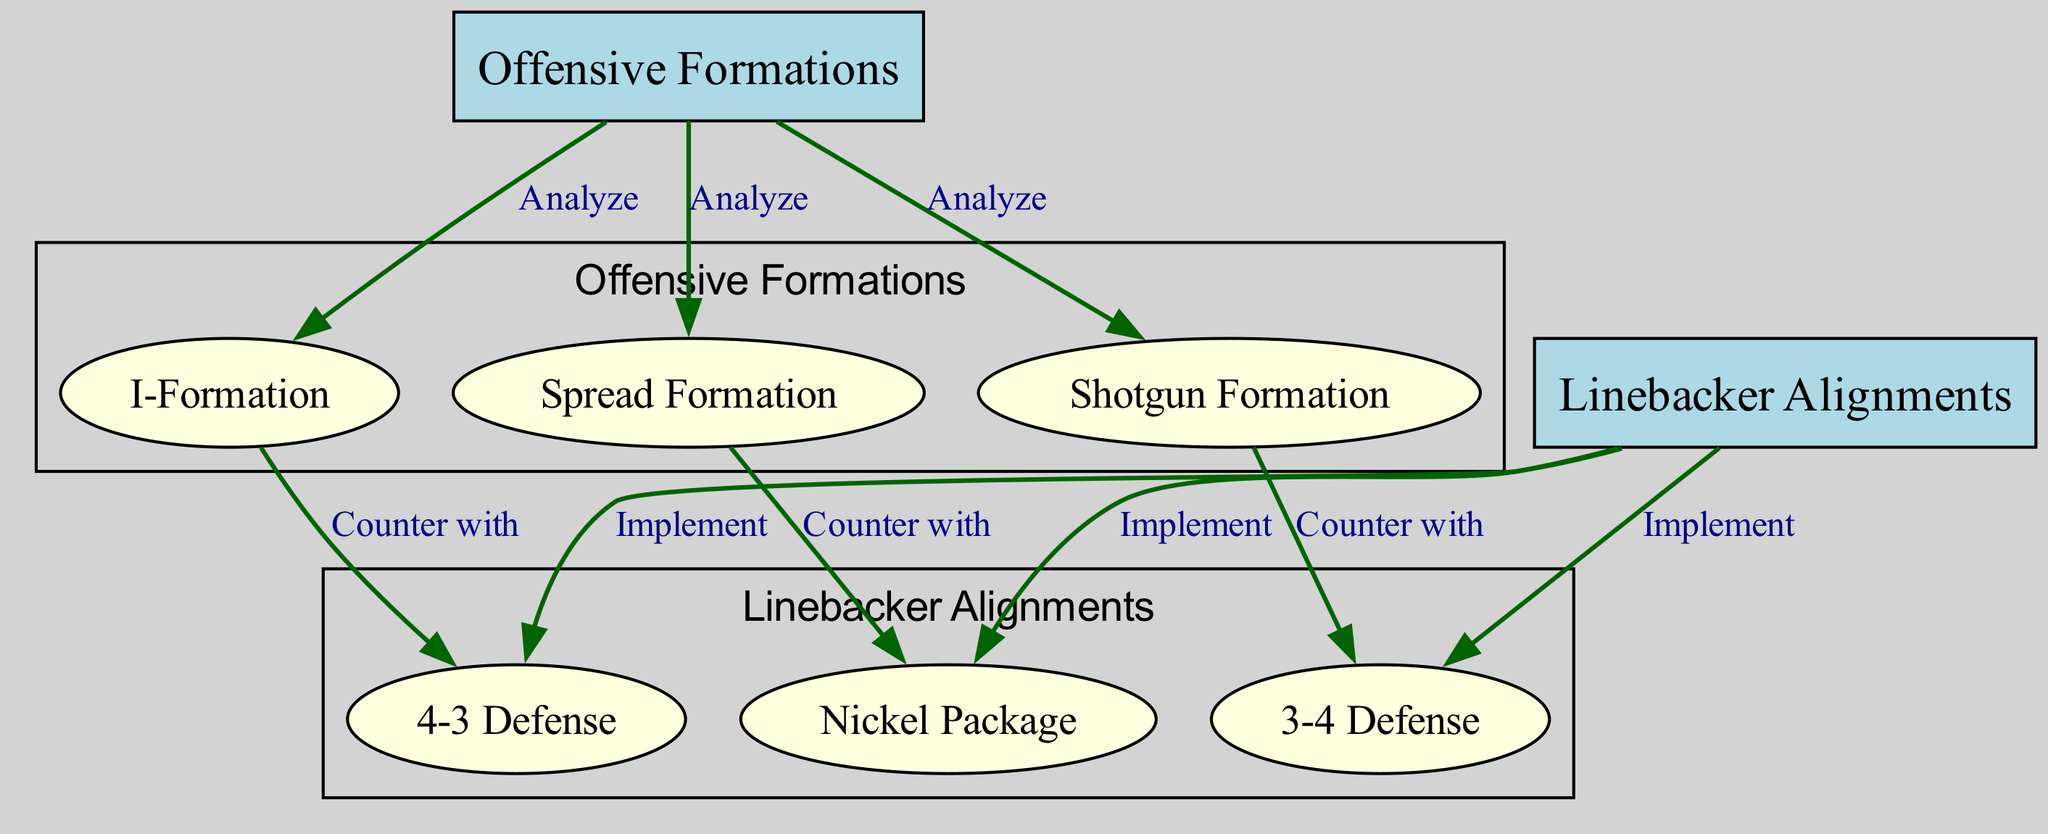What are the types of Offensive Formations listed? The diagram lists three types of offensive formations: Spread Formation, I-Formation, and Shotgun Formation. These are represented as individual nodes under the main node "Offensive Formations."
Answer: Spread Formation, I-Formation, Shotgun Formation What is the first layer of nodes in the diagram? The first layer contains two main nodes: "Offensive Formations" and "Linebacker Alignments." Under "Offensive Formations," there are three formations, while "Linebacker Alignments" leads to the three defensive schemes.
Answer: Offensive Formations, Linebacker Alignments How many nodes are connected to "Offensive Formations"? "Offensive Formations" connects to three nodes: Spread Formation, I-Formation, and Shotgun Formation, indicating the different types of formations analyzed.
Answer: 3 What does "Spread Formation" counter with? The label indicates that the "Spread Formation" is countered with the "Nickel Package," shown as an edge in the diagram connecting these two nodes.
Answer: Nickel Package Which linebacker alignment corresponds to the I-Formation? The I-Formation is countered with the "4-3 Defense," as depicted by the connecting edge that shows the relationship between the I-Formation and linebacker alignment.
Answer: 4-3 Defense Describe the relationship between "Shotgun Formation" and its counter. The "Shotgun Formation" is specifically countered with the "3-4 Defense," shown as a directed edge in the diagram that demonstrates the tactical response to this formation.
Answer: 3-4 Defense Which formations lead to their corresponding linebacker alignments? The diagram shows that the Spread Formation leads to the Nickel Package, the I-Formation leads to the 4-3 Defense, and the Shotgun Formation leads to the 3-4 Defense. These relationships are indicated by the directed edges from the formations to the respective defenses.
Answer: Spread Formation to Nickel Package, I-Formation to 4-3 Defense, Shotgun Formation to 3-4 Defense What is the purpose of the "Linebacker Alignments" node? The node "Linebacker Alignments" is essential as it encapsulates different linebacker formations, allowing teams to implement strategies based on the analyzed offensive formations. The edges indicate how defenses can respond effectively.
Answer: Implement strategies How many edges connect the "Linebacker Alignments" to its respective formations? There are three edges connecting the node "Linebacker Alignments" to its corresponding formations, indicating distinct defensive responses to the offensive formations analyzed.
Answer: 3 